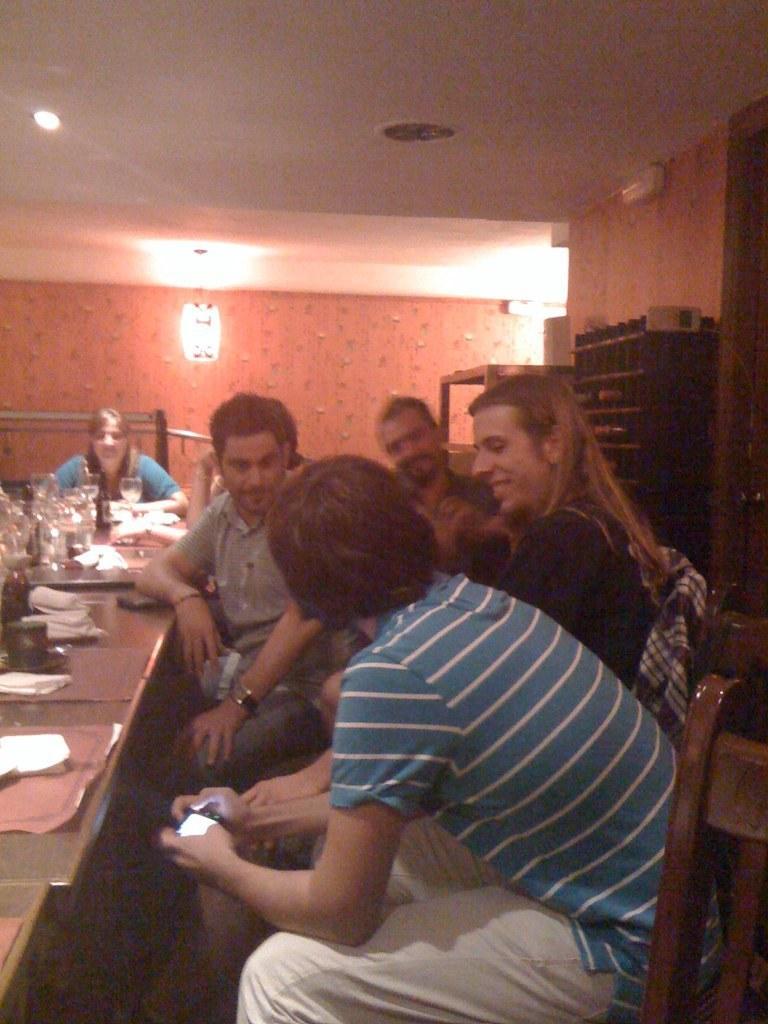In one or two sentences, can you explain what this image depicts? These persons sitting on the chair. there is a table. On the table we can see glasses,paper,things. On the background we can see wall. On the top we can see light. 